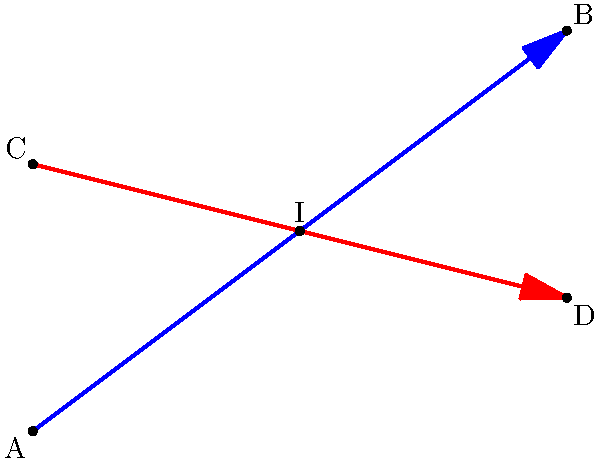Two patrol routes in a city are represented by the following linear equations:

Patrol Route 1: $y = \frac{3}{4}x$
Patrol Route 2: $y = -\frac{1}{4}x + 4$

At which point do these patrol routes intersect? Provide the coordinates of the intersection point. To find the intersection point of the two patrol routes, we need to solve the system of equations:

1) $y = \frac{3}{4}x$ (Patrol Route 1)
2) $y = -\frac{1}{4}x + 4$ (Patrol Route 2)

At the intersection point, the y-coordinates will be equal. So we can set the right sides of the equations equal to each other:

$$\frac{3}{4}x = -\frac{1}{4}x + 4$$

Now, let's solve for x:

$$\frac{3}{4}x + \frac{1}{4}x = 4$$
$$\frac{4}{4}x = 4$$
$$x = 4$$

To find the y-coordinate, we can substitute x = 4 into either of the original equations. Let's use Patrol Route 1:

$$y = \frac{3}{4}(4) = 3$$

Therefore, the intersection point is (4, 3).
Answer: (4, 3) 